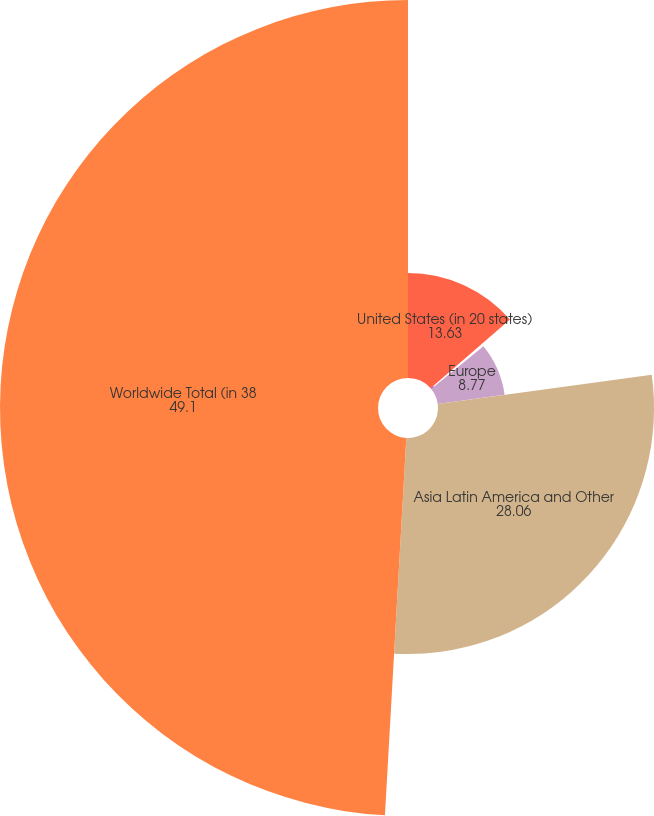Convert chart. <chart><loc_0><loc_0><loc_500><loc_500><pie_chart><fcel>United States (in 20 states)<fcel>Canada<fcel>Europe<fcel>Asia Latin America and Other<fcel>Worldwide Total (in 38<nl><fcel>13.63%<fcel>0.44%<fcel>8.77%<fcel>28.06%<fcel>49.1%<nl></chart> 